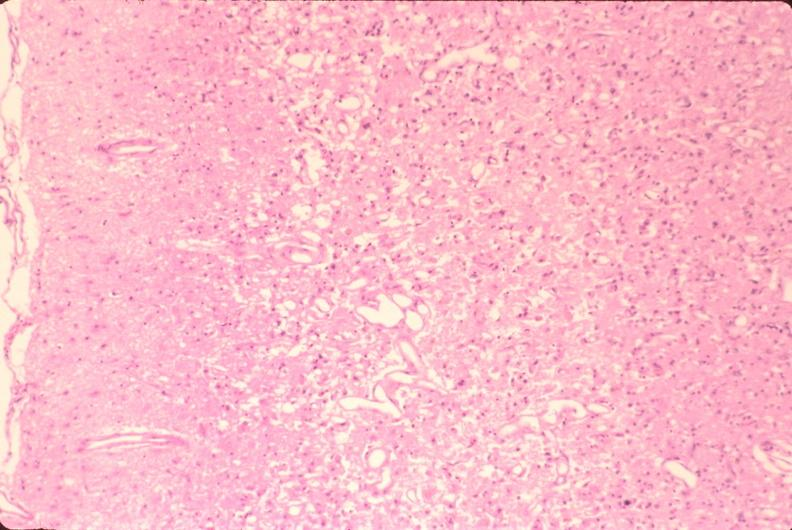where is this?
Answer the question using a single word or phrase. Nervous 